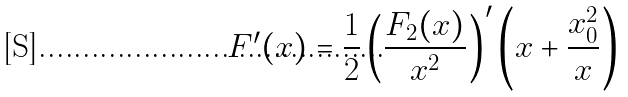Convert formula to latex. <formula><loc_0><loc_0><loc_500><loc_500>F ^ { \prime } ( x ) = \frac { 1 } { 2 } \left ( \frac { F _ { 2 } ( x ) } { x ^ { 2 } } \right ) ^ { \prime } \left ( x + \frac { x _ { 0 } ^ { 2 } } x \right )</formula> 